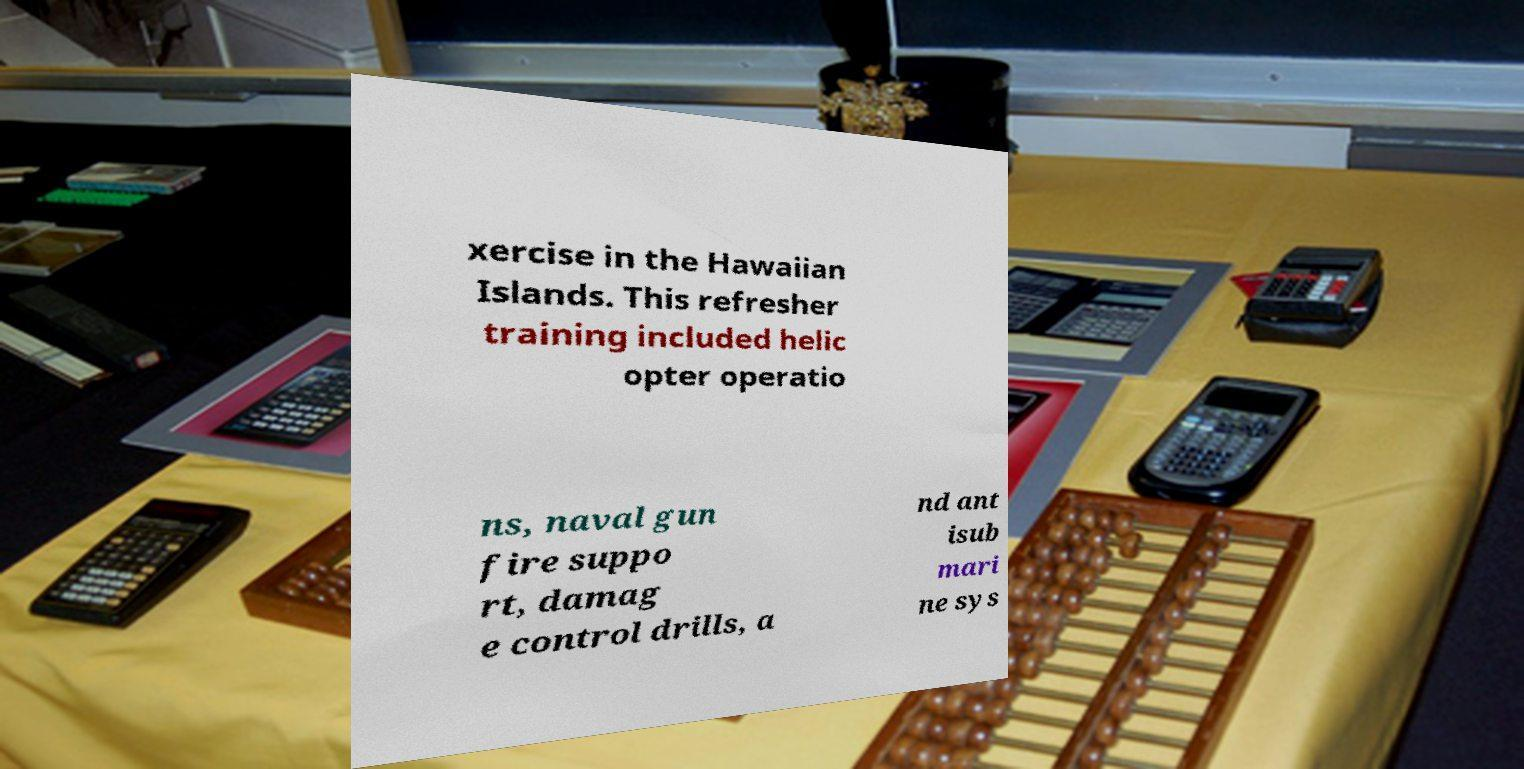Can you read and provide the text displayed in the image?This photo seems to have some interesting text. Can you extract and type it out for me? xercise in the Hawaiian Islands. This refresher training included helic opter operatio ns, naval gun fire suppo rt, damag e control drills, a nd ant isub mari ne sys 